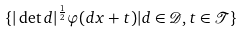<formula> <loc_0><loc_0><loc_500><loc_500>\{ | \det d | ^ { \frac { 1 } { 2 } } \varphi ( d x + t ) | d \in \mathcal { D } , t \in \mathcal { T } \}</formula> 